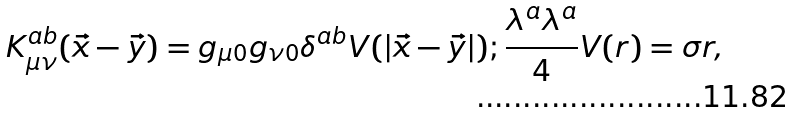Convert formula to latex. <formula><loc_0><loc_0><loc_500><loc_500>K ^ { a b } _ { \mu \nu } ( \vec { x } - \vec { y } ) = g _ { \mu 0 } g _ { \nu 0 } \delta ^ { a b } V ( | \vec { x } - \vec { y } | ) ; \frac { \lambda ^ { a } \lambda ^ { a } } { 4 } V ( r ) = \sigma r ,</formula> 